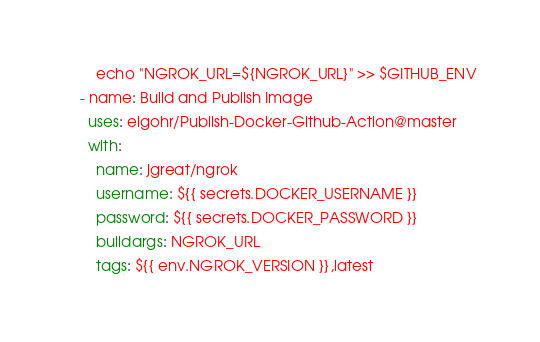<code> <loc_0><loc_0><loc_500><loc_500><_YAML_>        echo "NGROK_URL=${NGROK_URL}" >> $GITHUB_ENV
    - name: Build and Publish Image
      uses: elgohr/Publish-Docker-Github-Action@master
      with:
        name: jgreat/ngrok
        username: ${{ secrets.DOCKER_USERNAME }}
        password: ${{ secrets.DOCKER_PASSWORD }}
        buildargs: NGROK_URL
        tags: ${{ env.NGROK_VERSION }},latest
</code> 